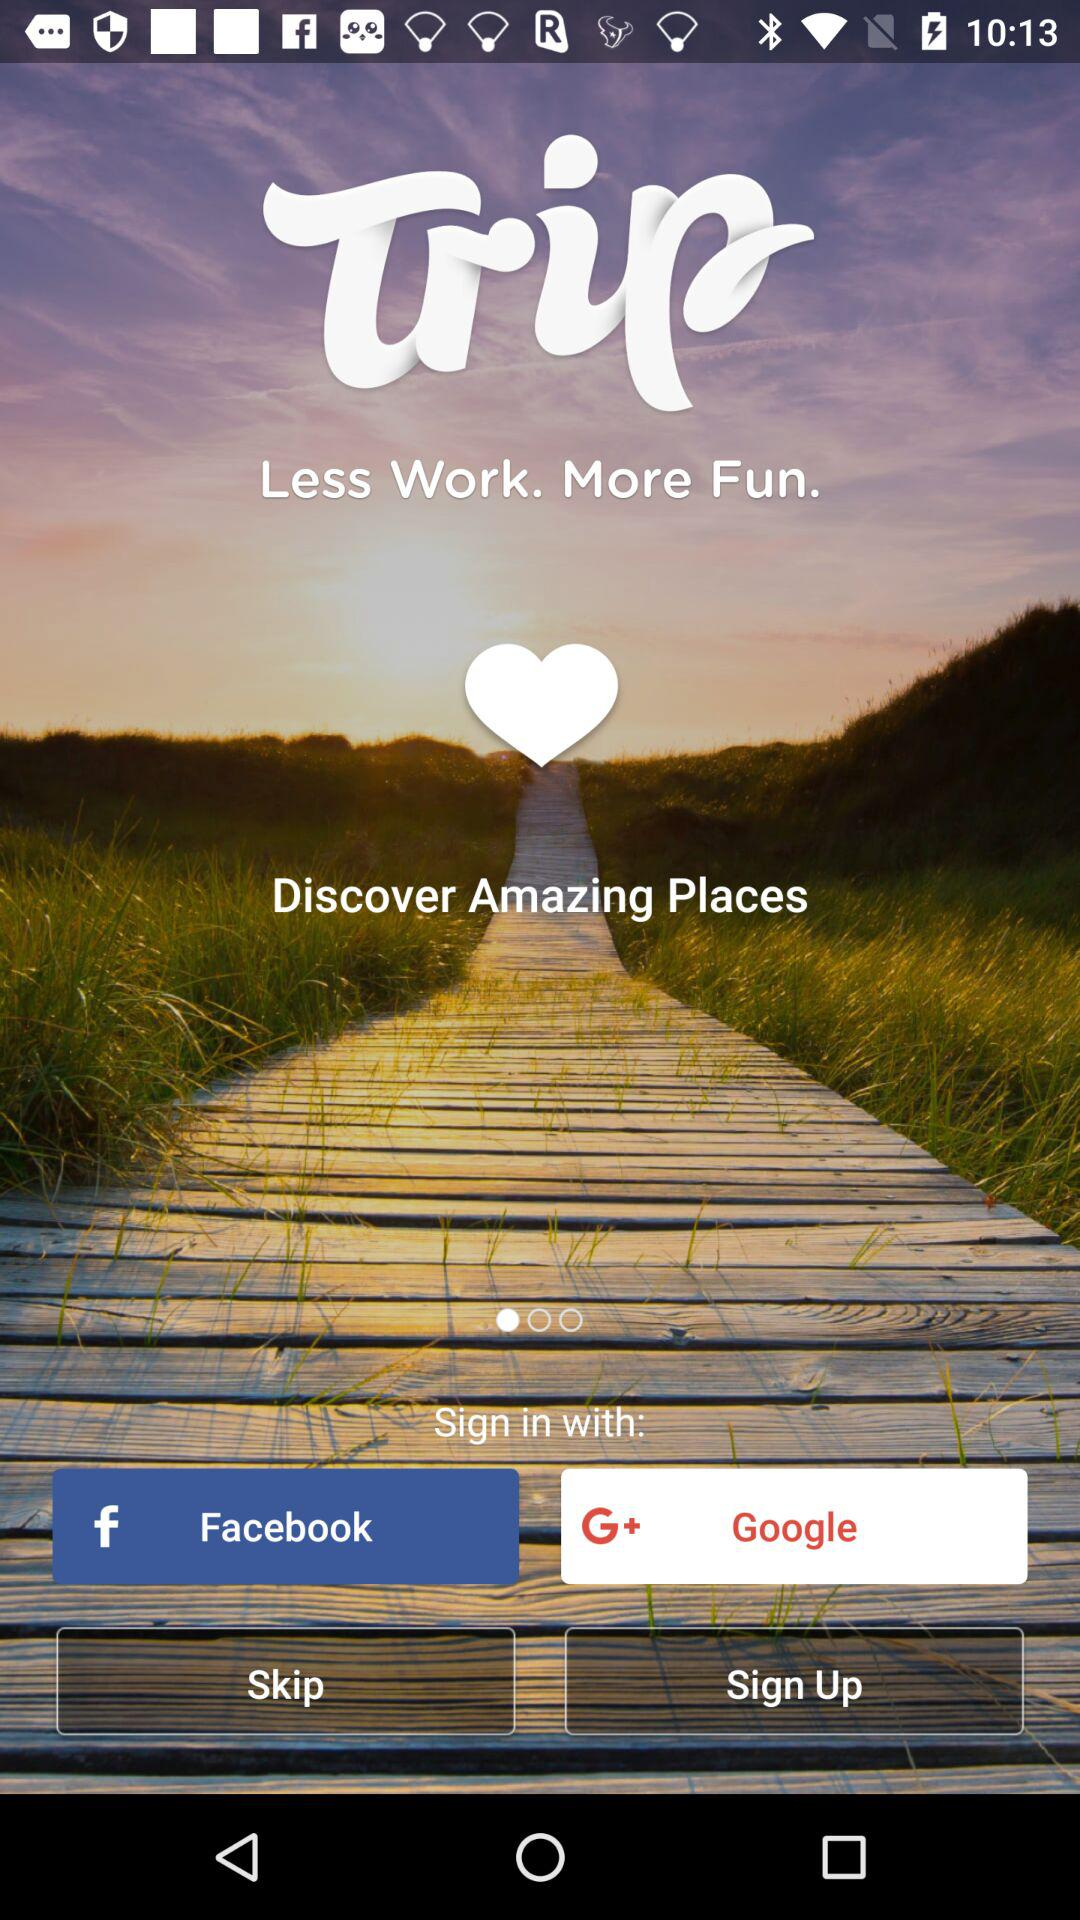Which applications can be used to sign in? The applications that can be used to sign in are "Facebook" and "Google". 